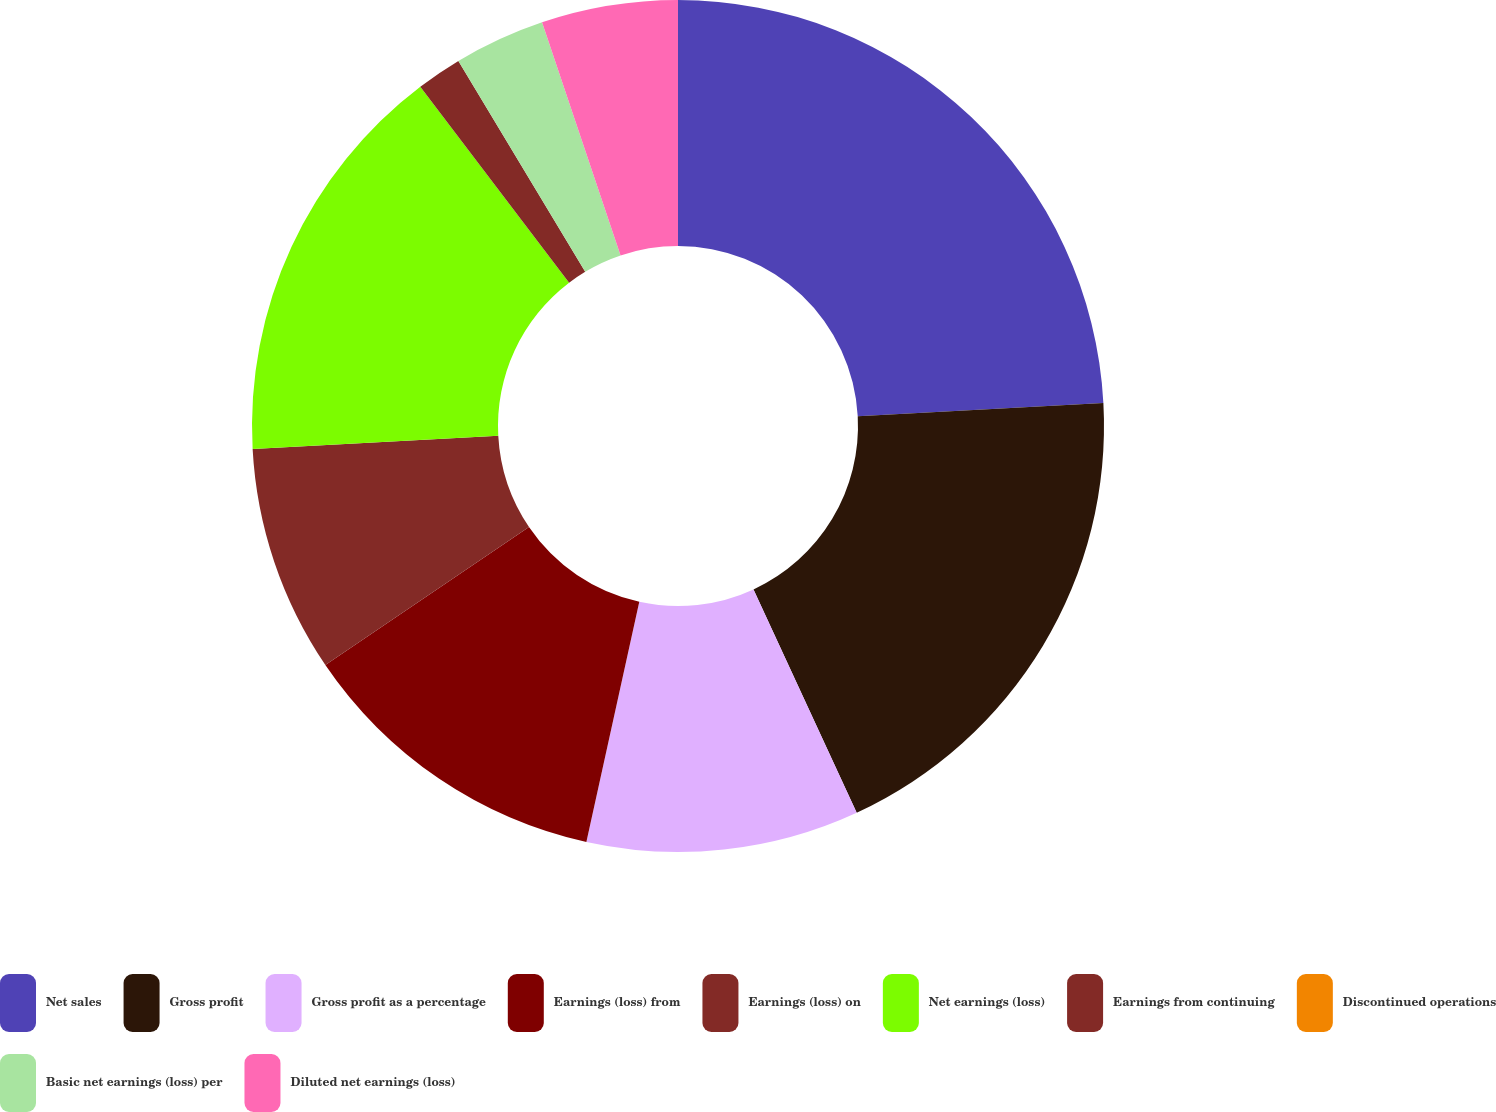Convert chart to OTSL. <chart><loc_0><loc_0><loc_500><loc_500><pie_chart><fcel>Net sales<fcel>Gross profit<fcel>Gross profit as a percentage<fcel>Earnings (loss) from<fcel>Earnings (loss) on<fcel>Net earnings (loss)<fcel>Earnings from continuing<fcel>Discontinued operations<fcel>Basic net earnings (loss) per<fcel>Diluted net earnings (loss)<nl><fcel>24.14%<fcel>18.97%<fcel>10.34%<fcel>12.07%<fcel>8.62%<fcel>15.52%<fcel>1.72%<fcel>0.0%<fcel>3.45%<fcel>5.17%<nl></chart> 